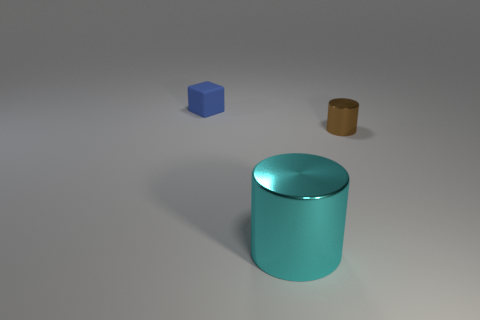Comparing the objects, what can you tell me about their sizes? Based on the image, the teal cylinder is the largest object both in terms of height and diameter. The blue cube is smaller in size than the teal cylinder, and the third object, which is brown, appears to be the smallest, chiefly in height but also in its diameter. And how does their size relate to their placement in the image? The objects are spaced apart from each other, with the largest object, the teal cylinder, being positioned prominently in the foreground. The blue cube and brown object are placed further back, accentuating the sense of depth and making the teal cylinder more of a focal point due to its size and positioning. 